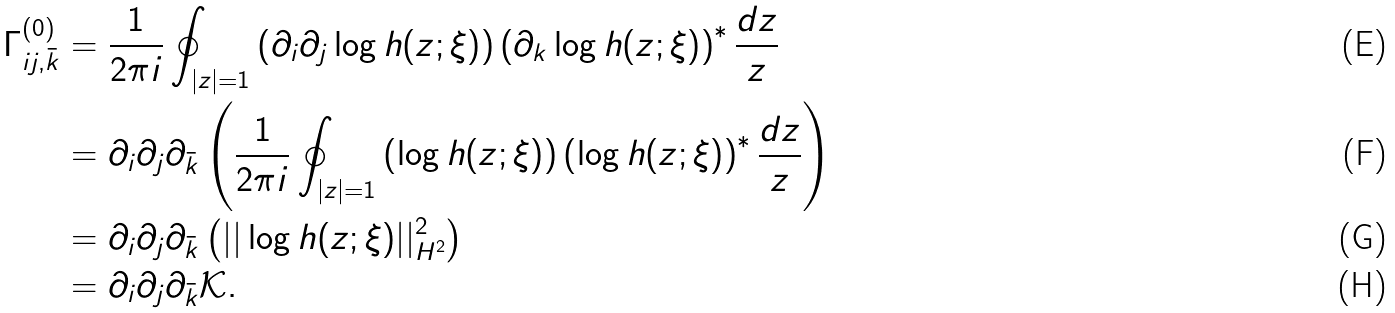<formula> <loc_0><loc_0><loc_500><loc_500>\Gamma ^ { ( 0 ) } _ { i j , \bar { k } } & = \frac { 1 } { 2 \pi i } \oint _ { | z | = 1 } \left ( \partial _ { i } \partial _ { j } \log { h ( z ; \xi ) } \right ) \left ( \partial _ { k } \log { h ( z ; \xi ) } \right ) ^ { * } \frac { d z } { z } \\ & = \partial _ { i } \partial _ { j } \partial _ { \bar { k } } \left ( \frac { 1 } { 2 \pi i } \oint _ { | z | = 1 } \left ( \log { h ( z ; \xi ) } \right ) \left ( \log { h ( z ; \xi ) } \right ) ^ { * } \frac { d z } { z } \right ) \\ & = \partial _ { i } \partial _ { j } \partial _ { \bar { k } } \left ( | | \log h ( z ; \xi ) | | ^ { 2 } _ { H ^ { 2 } } \right ) \\ & = \partial _ { i } \partial _ { j } \partial _ { \bar { k } } \mathcal { K } .</formula> 